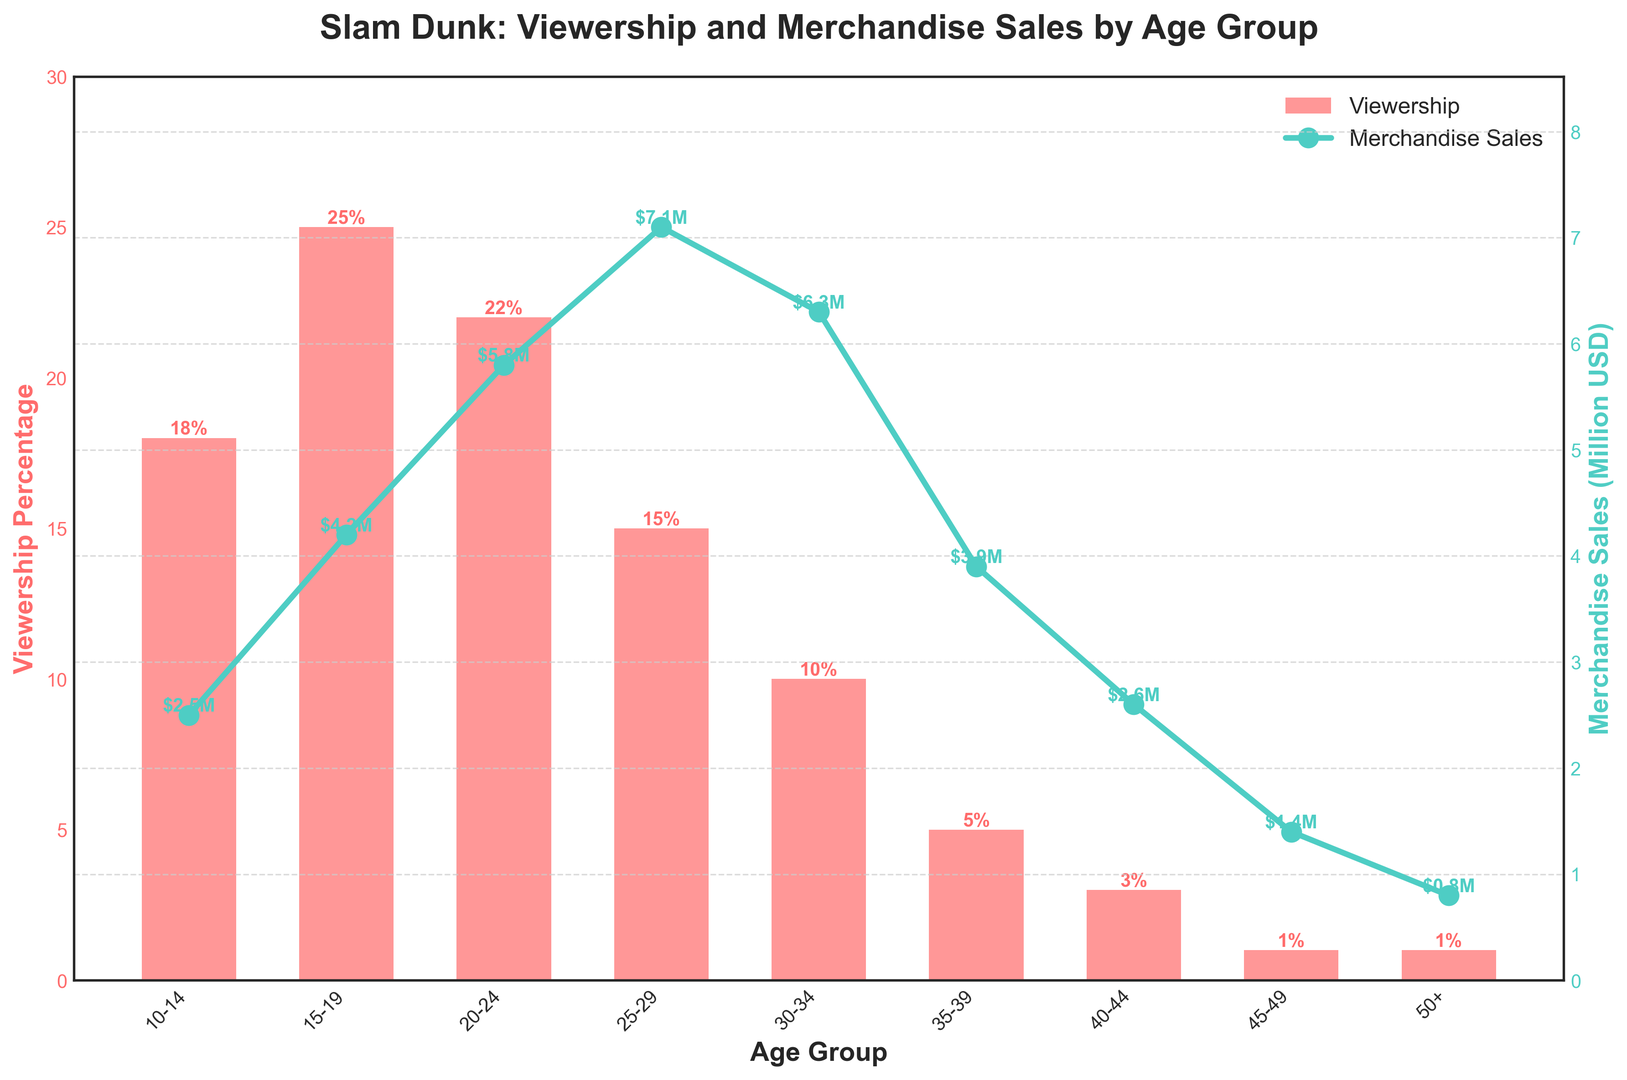Which age group has the highest viewership percentage? By looking at the height of the bars representing viewership percentages, the tallest bar corresponds to the age group with the highest viewership percentage. The age group 15-19 has the highest viewership percentage of 25%.
Answer: 15-19 How does merchandise sales for the 30-34 age group compare to the 10-14 age group? By comparing the points on the line plot, the merchandise sales for the 30-34 age group is $6.3 million, which is higher than the $2.5 million for the 10-14 age group.
Answer: Higher Which age group has the lowest merchandise sales and what is the amount? The lowest point on the line plot corresponds to the age group with the lowest merchandise sales. The age group 50+ has the lowest merchandise sales at $0.8 million.
Answer: 50+, $0.8 million What is the total viewership percentage for the age groups 25-29 and 30-34? Adding the viewership percentages of the age groups 25-29 (15%) and 30-34 (10%) gives a total of 15% + 10% = 25%.
Answer: 25% What is the difference in merchandise sales between the age groups 20-24 and 40-44? The merchandise sales for the age group 20-24 is $5.8 million, and for the age group 40-44 is $2.6 million. The difference is $5.8 million - $2.6 million = $3.2 million.
Answer: $3.2 million Which age group(s) have both viewership percentage and merchandise sales labeled on the plot? Observing the text labels on the bars and points, all age groups have both their viewership percentages and merchandise sales values labeled.
Answer: All What is the average merchandise sales for the age groups 15-19, 25-29, and 35-39? The merchandise sales for these age groups are $4.2 million, $7.1 million, and $3.9 million respectively. Adding these values and dividing by 3 gives the average: ($4.2 million + $7.1 million + $3.9 million)/3 = $5.07 million.
Answer: $5.07 million Which age group has the closest viewership percentage to the average viewership percentage across all age groups? The total sum of viewership percentages is 100% over 9 age groups, so the average viewership percentage is 100% / 9 ≈ 11.1%. The age group 30-34 with 10% viewership is closest to this average.
Answer: 30-34 